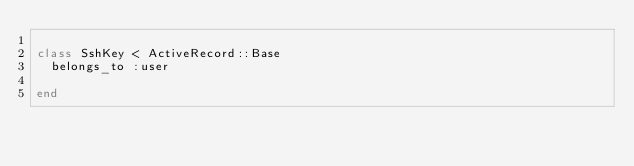Convert code to text. <code><loc_0><loc_0><loc_500><loc_500><_Ruby_>
class SshKey < ActiveRecord::Base
  belongs_to :user
  
end
</code> 